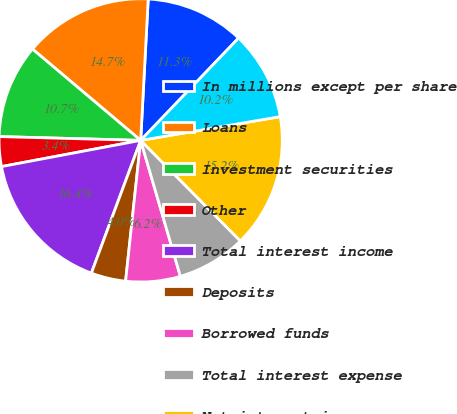<chart> <loc_0><loc_0><loc_500><loc_500><pie_chart><fcel>In millions except per share<fcel>Loans<fcel>Investment securities<fcel>Other<fcel>Total interest income<fcel>Deposits<fcel>Borrowed funds<fcel>Total interest expense<fcel>Net interest income<fcel>Asset management<nl><fcel>11.3%<fcel>14.69%<fcel>10.73%<fcel>3.39%<fcel>16.38%<fcel>3.96%<fcel>6.22%<fcel>7.91%<fcel>15.25%<fcel>10.17%<nl></chart> 